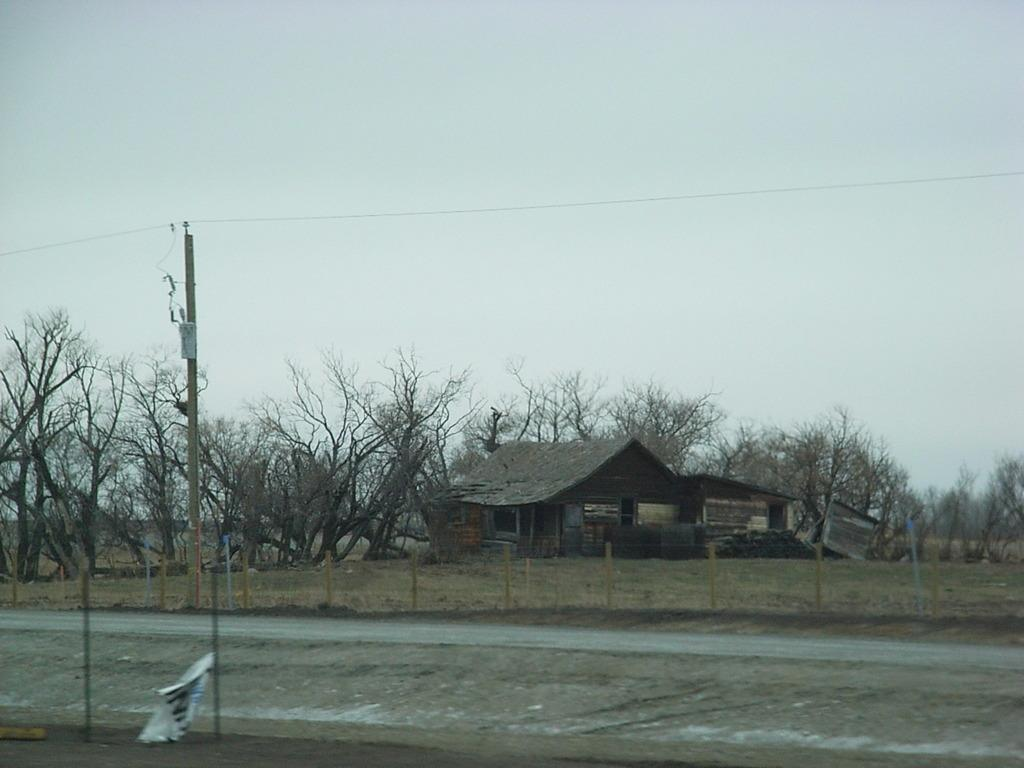What structures are present in the image? There are poles, huts, and a banner in the image. What type of natural elements can be seen in the image? There are trees in the image. What man-made feature is visible in the image? There is a road in the image. What is visible in the background of the image? The sky is visible in the background of the image. Can you tell me how many toes are visible on the doctor's foot in the image? There is no doctor or foot present in the image; it features poles, trees, huts, a road, a banner, and the sky. 